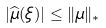<formula> <loc_0><loc_0><loc_500><loc_500>| \widehat { \mu } ( \xi ) | \leq \| \mu \| _ { * }</formula> 